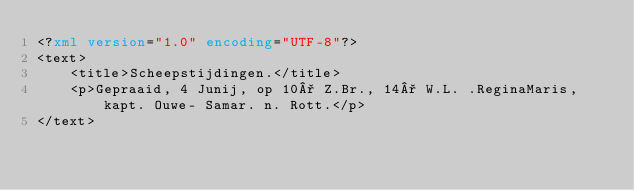Convert code to text. <code><loc_0><loc_0><loc_500><loc_500><_XML_><?xml version="1.0" encoding="UTF-8"?>
<text>
	<title>Scheepstijdingen.</title>
	<p>Gepraaid, 4 Junij, op 10° Z.Br., 14° W.L. .ReginaMaris, kapt. Ouwe- Samar. n. Rott.</p>
</text>
</code> 